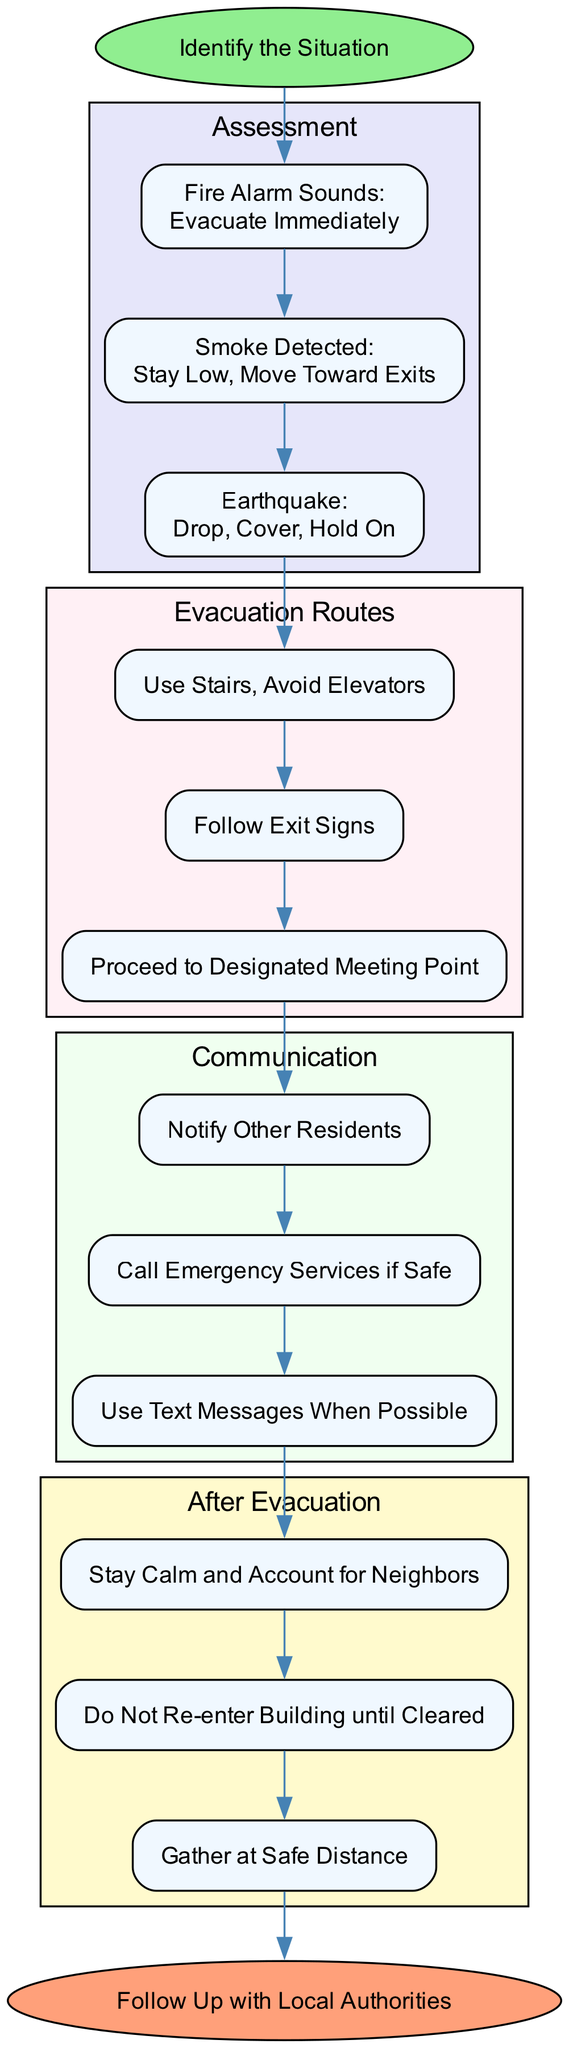What is the first action to take when the fire alarm sounds? According to the flow chart, when the fire alarm sounds, the immediate action indicated is to evacuate immediately.
Answer: Evacuate Immediately How many assessment actions are there? The flow chart shows there are three assessment actions listed: fire alarm, smoke detected, and earthquake. By counting them, we conclude that there are three actions.
Answer: 3 What should you do if smoke is detected? The chart states that if smoke is detected, the action to take is to stay low and move toward exits. This information is directly taken from the assessment section of the flow chart.
Answer: Stay Low, Move Toward Exits Which evacuation route is mentioned first? In the evacuation routes section of the diagram, the first suggested route is to use stairs and avoid elevators. This is identified as the first item in the list of evacuation routes.
Answer: Use Stairs, Avoid Elevators What do you need to do after evacuation according to the diagram? The diagram indicates that after evacuation, you should stay calm and account for neighbors. This is the first step listed in the after evacuation section.
Answer: Stay Calm and Account for Neighbors Which step follows notifying other residents? The flow chart shows a sequence where, after notifying other residents, the next step is to call emergency services if safe to do so. This helps to establish the order of actions in the communication section.
Answer: Call Emergency Services if Safe What indicates the end of the evacuation process? The end of the evacuation process, as indicated on the flow chart, is to follow up with local authorities, making this the final step shown.
Answer: Follow Up with Local Authorities How is the flow of actions depicted in the diagram? The diagram represents the flow of actions as a sequence of nodes connected by edges, indicating the order of operations from identifying the situation through to after evacuation and ending with following up with authorities. One can trace from start to end to see the flow.
Answer: Sequential Nodes and Edges What color are the nodes representing the evacuation routes? The nodes representing the evacuation routes are filled with a light pink color, distinctly separating them from other sections in the flow chart.
Answer: Light Pink 